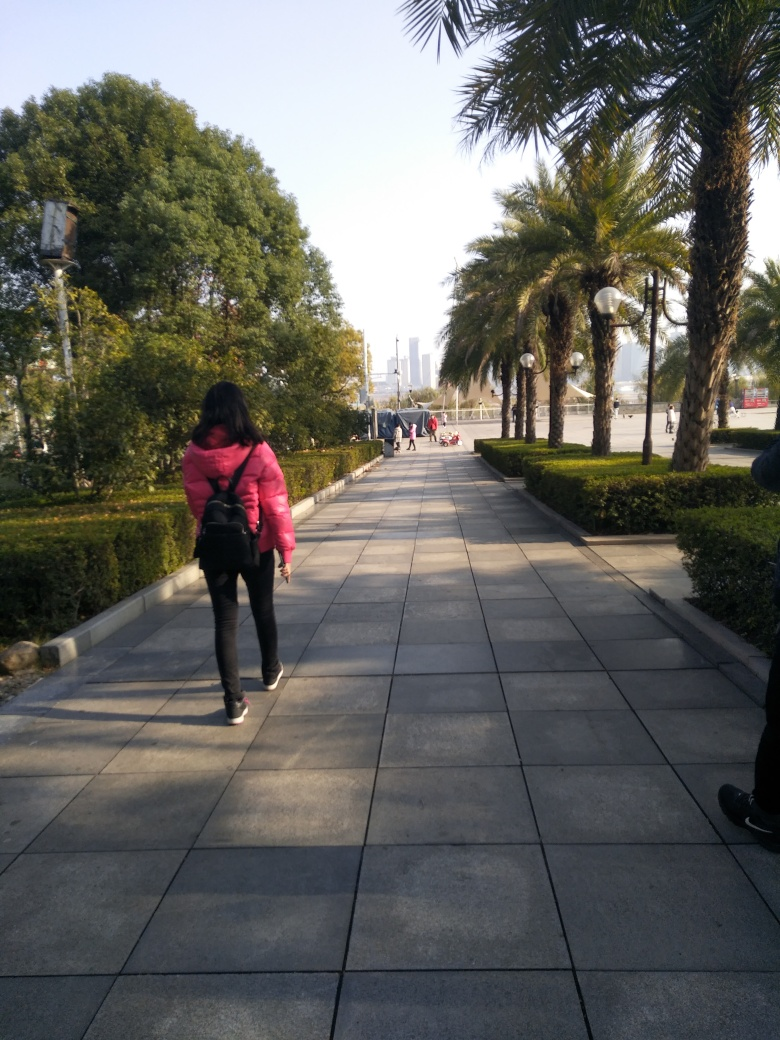Can you comment on the activities of the individuals in the image? Most individuals visible in the image seem to be engaged in leisurely walking or strolling through the area, enjoying the outdoor environment. The central figure dressed in a pink jacket appears to be walking with purpose, perhaps commuting or heading towards a specific destination. There do not appear to be any group activities or interactions occurring within the frame, and everyone seems to be observing social spacing. 